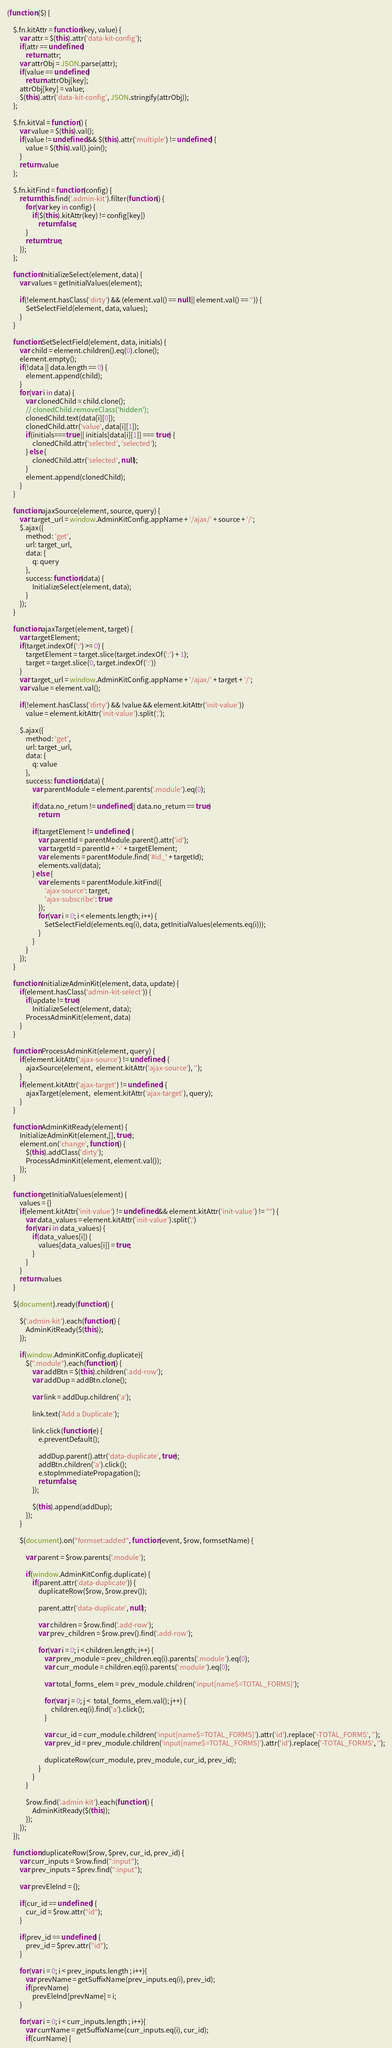Convert code to text. <code><loc_0><loc_0><loc_500><loc_500><_JavaScript_>(function ($) {

    $.fn.kitAttr = function(key, value) {
        var attr = $(this).attr('data-kit-config');
        if(attr == undefined)
            return attr;
        var attrObj = JSON.parse(attr);
        if(value == undefined)
            return attrObj[key];
        attrObj[key] = value;
        $(this).attr('data-kit-config', JSON.stringify(attrObj));
    };

    $.fn.kitVal = function() {
        var value = $(this).val();
        if(value != undefined && $(this).attr('multiple') != undefined) {
            value = $(this).val().join();
        }
        return value
    };

    $.fn.kitFind = function(config) {
        return this.find('.admin-kit').filter(function() {
            for(var key in config) {
                if($(this).kitAttr(key) != config[key])
                    return false;
            }
            return true;
        });
    };

    function InitializeSelect(element, data) {
        var values = getInitialValues(element);
        
        if(!element.hasClass('dirty') && (element.val() == null || element.val() == '')) {
            SetSelectField(element, data, values);
        }
    }

    function SetSelectField(element, data, initials) {
        var child = element.children().eq(0).clone();
        element.empty();
        if(!data || data.length == 0) {
            element.append(child);
        }
        for(var i in data) {
            var clonedChild = child.clone();
            // clonedChild.removeClass('hidden');
            clonedChild.text(data[i][0]);
            clonedChild.attr('value', data[i][1]);
            if(initials===true || initials[data[i][1]] === true) {
                clonedChild.attr('selected', 'selected');
            } else {
                clonedChild.attr('selected', null);
            }
            element.append(clonedChild);
        }
    }

    function ajaxSource(element, source, query) {
        var target_url = window.AdminKitConfig.appName + '/ajax/' + source + '/';
        $.ajax({
            method: 'get',
            url: target_url,
            data: {
                q: query
            },
            success: function(data) {
                InitializeSelect(element, data);
            }
        });
    }

    function ajaxTarget(element, target) {
        var targetElement;
        if(target.indexOf(':') >= 0) {
            targetElement = target.slice(target.indexOf(':') + 1);
            target = target.slice(0, target.indexOf(':'))
        }
        var target_url = window.AdminKitConfig.appName + '/ajax/' + target + '/';
        var value = element.val();

        if(!element.hasClass('dirty') && !value && element.kitAttr('init-value'))
            value = element.kitAttr('init-value').split(',');

        $.ajax({
            method: 'get',
            url: target_url,
            data: {
                q: value
            },
            success: function(data) {
                var parentModule = element.parents('.module').eq(0);

                if(data.no_return != undefined || data.no_return == true)
                    return

                if(targetElement != undefined) {
                    var parentId = parentModule.parent().attr('id');
                    var targetId = parentId + '-' + targetElement;
                    var elements = parentModule.find('#id_' + targetId);
                    elements.val(data);
                } else {
                    var elements = parentModule.kitFind({
                        'ajax-source': target,
                        'ajax-subscribe': true
                    });
                    for(var i = 0; i < elements.length; i++) {
                        SetSelectField(elements.eq(i), data, getInitialValues(elements.eq(i)));
                    }
                }
            }
        });
    }

    function InitializeAdminKit(element, data, update) {
        if(element.hasClass('admin-kit-select')) {
            if(update != true)
                InitializeSelect(element, data);
            ProcessAdminKit(element, data)
        }
    }

    function ProcessAdminKit(element, query) {
        if(element.kitAttr('ajax-source') != undefined) {
            ajaxSource(element,  element.kitAttr('ajax-source'), '');
        }
        if(element.kitAttr('ajax-target') != undefined) {
            ajaxTarget(element,  element.kitAttr('ajax-target'), query);
        }
    }

    function AdminKitReady(element) {
        InitializeAdminKit(element,[], true);
        element.on('change', function() {
            $(this).addClass('dirty');
            ProcessAdminKit(element, element.val());
        });
    }

    function getInitialValues(element) {
        values = {}
        if(element.kitAttr('init-value') != undefined && element.kitAttr('init-value') != "") {
            var data_values = element.kitAttr('init-value').split(',')
            for(var i in data_values) {
                if(data_values[i]) {
                    values[data_values[i]] = true;
                }
            }
        }
        return values
    }

    $(document).ready(function() {

        $('.admin-kit').each(function() {
            AdminKitReady($(this));
        });

        if(window.AdminKitConfig.duplicate){
            $(".module").each(function() {
                var addBtn = $(this).children('.add-row');
                var addDup = addBtn.clone();
    
                var link = addDup.children('a');
    
                link.text('Add a Duplicate');
    
                link.click(function(e) {
                    e.preventDefault();
    
                    addDup.parent().attr('data-duplicate', true);
                    addBtn.children('a').click();
                    e.stopImmediatePropagation();
                    return false;
                });
    
                $(this).append(addDup);
            });
        }

        $(document).on("formset:added", function(event, $row, formsetName) {

            var parent = $row.parents('.module');
            
            if(window.AdminKitConfig.duplicate) {
                if(parent.attr('data-duplicate')) {
                    duplicateRow($row, $row.prev());
    
                    parent.attr('data-duplicate', null);
    
                    var children = $row.find('.add-row');
                    var prev_children = $row.prev().find('.add-row');
    
                    for(var i = 0; i < children.length; i++) {
                        var prev_module = prev_children.eq(i).parents('.module').eq(0);
                        var curr_module = children.eq(i).parents('.module').eq(0);
                        
                        var total_forms_elem = prev_module.children('input[name$=TOTAL_FORMS]');
    
                        for(var j = 0; j <  total_forms_elem.val(); j++) {
                            children.eq(i).find('a').click();
                        }
    
                        var cur_id = curr_module.children('input[name$=TOTAL_FORMS]').attr('id').replace('-TOTAL_FORMS', '');
                        var prev_id = prev_module.children('input[name$=TOTAL_FORMS]').attr('id').replace('-TOTAL_FORMS', '');
    
                        duplicateRow(curr_module, prev_module, cur_id, prev_id);
                    }
                }
            }

            $row.find('.admin-kit').each(function() {
                AdminKitReady($(this));
            });
        });
    });

    function duplicateRow($row, $prev, cur_id, prev_id) {
        var curr_inputs = $row.find(":input");
        var prev_inputs = $prev.find(":input");
        
        var prevEleInd = {};

        if(cur_id == undefined) {
            cur_id = $row.attr("id");
        }

        if(prev_id == undefined) {
            prev_id = $prev.attr("id");
        }
    
        for(var i = 0; i < prev_inputs.length ; i++){
            var prevName = getSuffixName(prev_inputs.eq(i), prev_id);
            if(prevName)
                prevEleInd[prevName] = i;
        }
    
        for(var i = 0; i < curr_inputs.length ; i++){
            var currName = getSuffixName(curr_inputs.eq(i), cur_id);
            if(currName) {</code> 